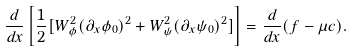Convert formula to latex. <formula><loc_0><loc_0><loc_500><loc_500>\frac { d } { d x } \left [ \frac { 1 } { 2 } [ W _ { \phi } ^ { 2 } ( \partial _ { x } \phi _ { 0 } ) ^ { 2 } + W _ { \psi } ^ { 2 } ( \partial _ { x } \psi _ { 0 } ) ^ { 2 } ] \right ] = \frac { d } { d x } ( f - \mu c ) .</formula> 